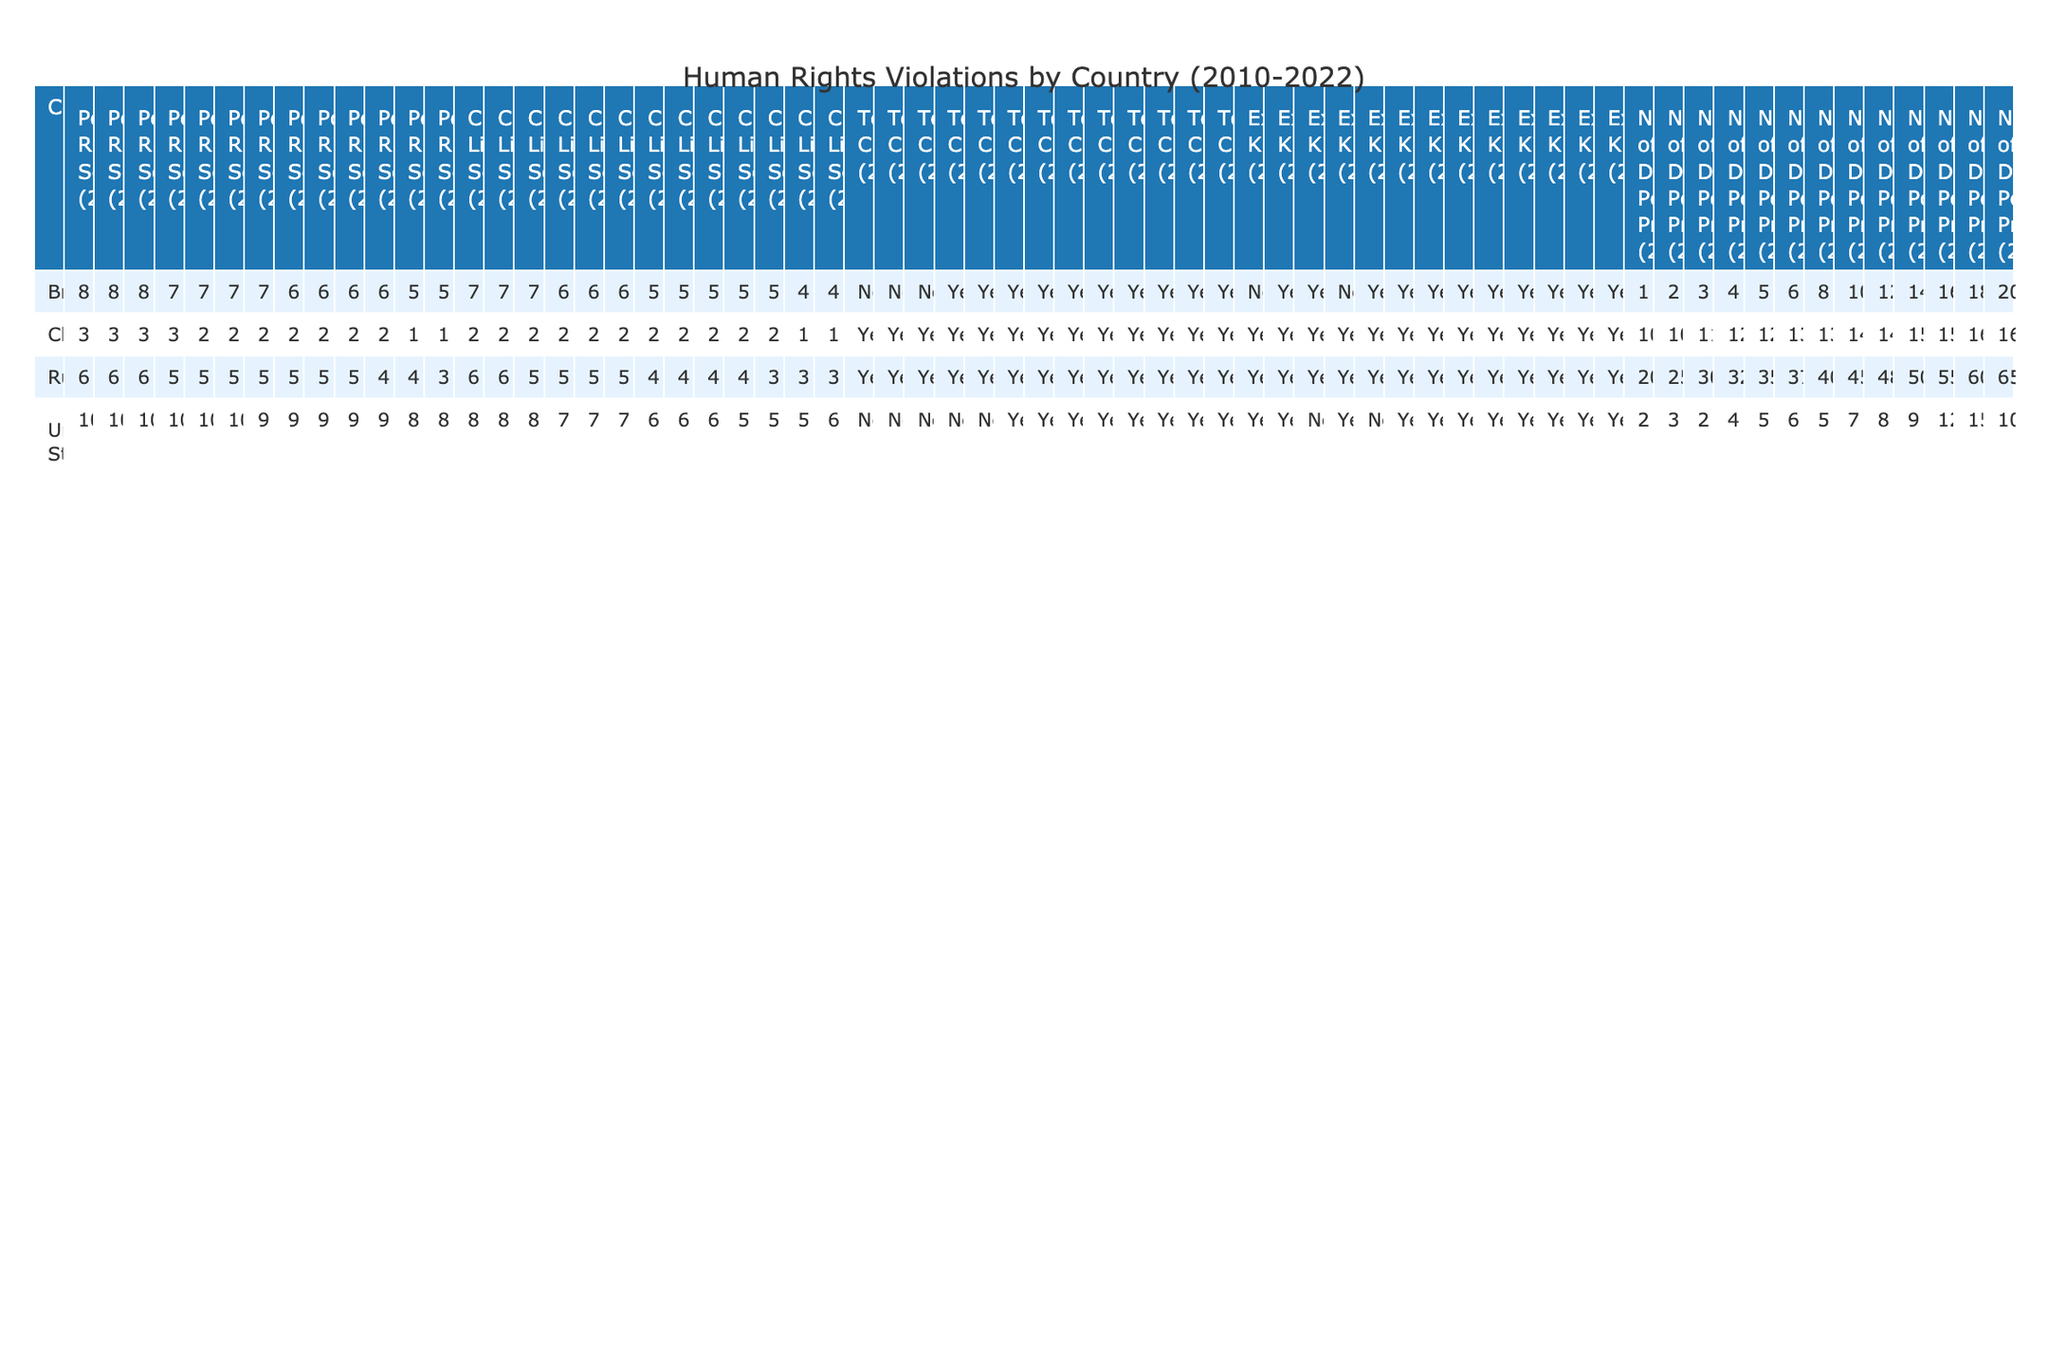What was the Political Rights Score of the United States in 2015? From the table, under the column for Political Rights Score corresponding to the year 2015 for the United States, the score is listed as 10.
Answer: 10 What is the maximum number of detained political prisoners reported in Russia during the years logged? By reviewing the column for the Number of Detained Political Prisoners for Russia, the highest number reported is 65 in 2022.
Answer: 65 Did Brazil have any years with Torture Claims recorded as "No"? The Torture Claims column for Brazil shows "No" for the years 2010 and 2011.
Answer: Yes What was the average Civil Liberties Score for China from 2010 to 2022? The Civil Liberties Scores for China over the years are 2, 2, 2, 2, 2, 2, 2, 2, 2, 2, 1, and 1. Summing these gives a total of 22. Dividing by 13 years results in an average Civil Liberties Score of approximately 1.69.
Answer: Approximately 1.69 What year did the United States see its highest number of detained political prisoners, and how many were reported? Looking through the table for the United States, the year with the highest number of detained political prisoners is 2021 with 15 reported.
Answer: 2021, 15 Was there a decrease in the Political Rights Score for Russia from 2010 to 2022? By comparing the Political Rights Scores for Russia, it declined from 6 in 2010 to 3 in 2022, indicating a decrease.
Answer: Yes Which country had the most Torture Claims filed across all years listed in the table? Analyzing the Torture Claims column, both China and Russia consistently have "Yes" from 2010 to 2022, showing the most claims filed.
Answer: China and Russia How many total Extrajudicial Killings were reported in the United States from 2010 to 2022? Totaling the Extrajudicial Killings for the United States gives 13 instances across the years logged.
Answer: 13 Identify the year in which Brazil had the lowest Civil Liberties Score and state that score. In examining Brazil's Civil Liberties Scores, the lowest score is 4 in both 2021 and 2022.
Answer: 4 (2021 and 2022) How does the number of detained political prisoners in the U.S. in 2022 compare with that in 2010? In 2010, the number was 2, and in 2022 it was 10; there was an increase of 8 prisoners over this period.
Answer: Increased by 8 